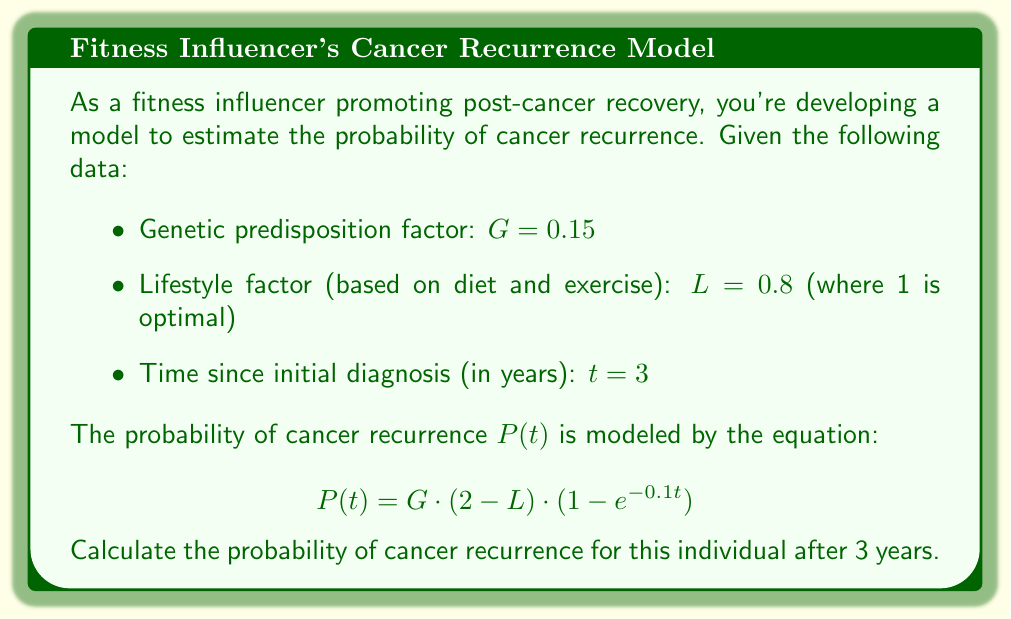Can you answer this question? To solve this problem, we'll follow these steps:

1) We have the equation for the probability of cancer recurrence:
   $$P(t) = G \cdot (2 - L) \cdot (1 - e^{-0.1t})$$

2) We're given the following values:
   - $G = 0.15$ (genetic predisposition factor)
   - $L = 0.8$ (lifestyle factor)
   - $t = 3$ (time since initial diagnosis in years)

3) Let's substitute these values into the equation:
   $$P(3) = 0.15 \cdot (2 - 0.8) \cdot (1 - e^{-0.1 \cdot 3})$$

4) First, let's calculate $(2 - L)$:
   $2 - 0.8 = 1.2$

5) Next, let's calculate $(1 - e^{-0.1t})$:
   $1 - e^{-0.1 \cdot 3} = 1 - e^{-0.3} \approx 1 - 0.7408 = 0.2592$

6) Now we can multiply all parts together:
   $$P(3) = 0.15 \cdot 1.2 \cdot 0.2592$$

7) Calculating this:
   $$P(3) = 0.046656$$

8) Converting to a percentage:
   $$P(3) \approx 4.67\%$$
Answer: The probability of cancer recurrence for this individual after 3 years is approximately 4.67%. 